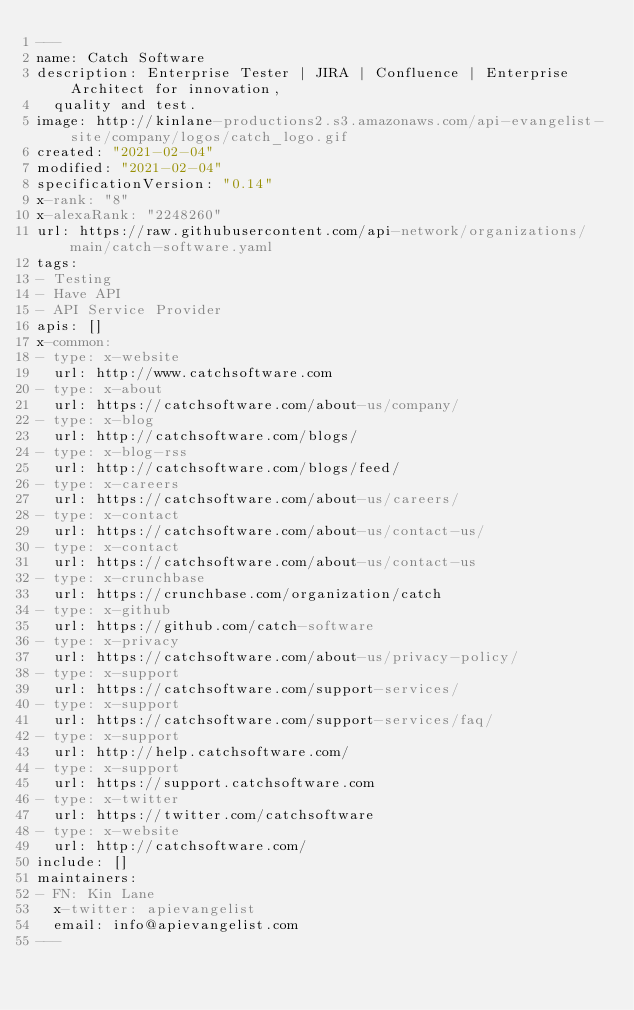<code> <loc_0><loc_0><loc_500><loc_500><_YAML_>---
name: Catch Software
description: Enterprise Tester | JIRA | Confluence | Enterprise Architect for innovation,
  quality and test.
image: http://kinlane-productions2.s3.amazonaws.com/api-evangelist-site/company/logos/catch_logo.gif
created: "2021-02-04"
modified: "2021-02-04"
specificationVersion: "0.14"
x-rank: "8"
x-alexaRank: "2248260"
url: https://raw.githubusercontent.com/api-network/organizations/main/catch-software.yaml
tags:
- Testing
- Have API
- API Service Provider
apis: []
x-common:
- type: x-website
  url: http://www.catchsoftware.com
- type: x-about
  url: https://catchsoftware.com/about-us/company/
- type: x-blog
  url: http://catchsoftware.com/blogs/
- type: x-blog-rss
  url: http://catchsoftware.com/blogs/feed/
- type: x-careers
  url: https://catchsoftware.com/about-us/careers/
- type: x-contact
  url: https://catchsoftware.com/about-us/contact-us/
- type: x-contact
  url: https://catchsoftware.com/about-us/contact-us
- type: x-crunchbase
  url: https://crunchbase.com/organization/catch
- type: x-github
  url: https://github.com/catch-software
- type: x-privacy
  url: https://catchsoftware.com/about-us/privacy-policy/
- type: x-support
  url: https://catchsoftware.com/support-services/
- type: x-support
  url: https://catchsoftware.com/support-services/faq/
- type: x-support
  url: http://help.catchsoftware.com/
- type: x-support
  url: https://support.catchsoftware.com
- type: x-twitter
  url: https://twitter.com/catchsoftware
- type: x-website
  url: http://catchsoftware.com/
include: []
maintainers:
- FN: Kin Lane
  x-twitter: apievangelist
  email: info@apievangelist.com
---</code> 